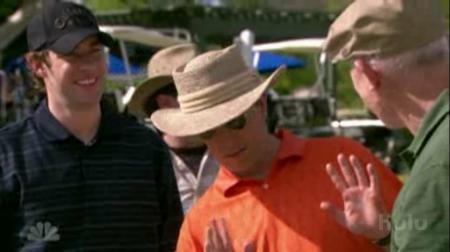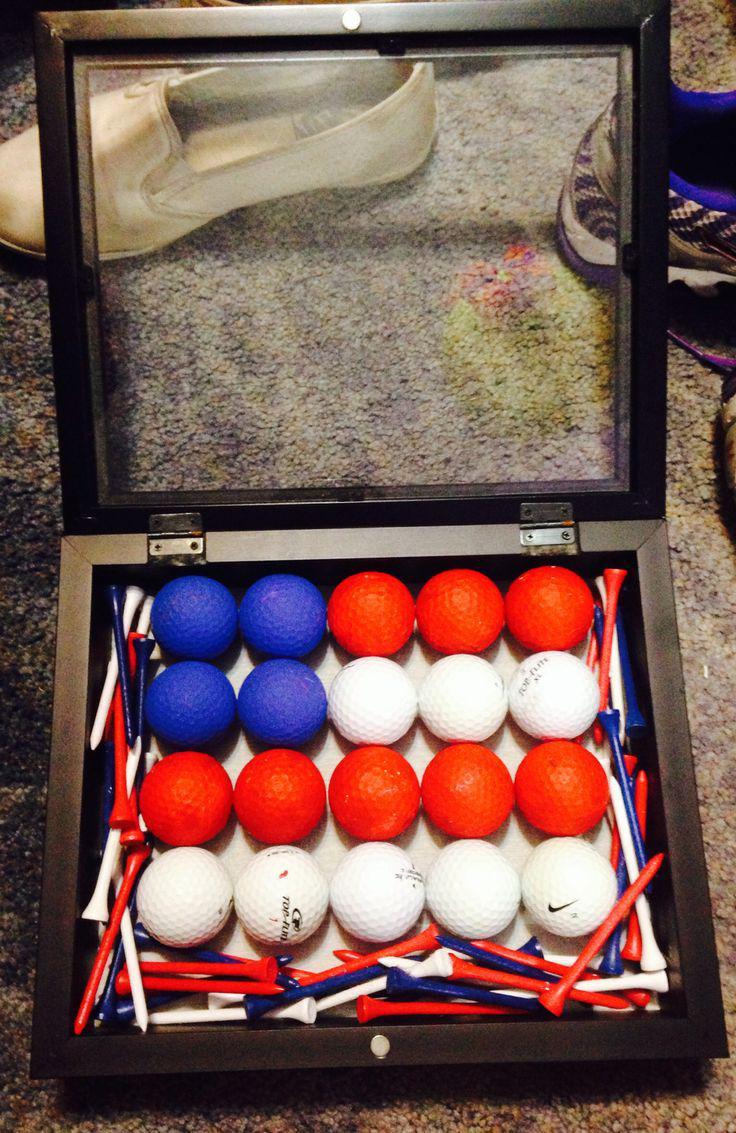The first image is the image on the left, the second image is the image on the right. Considering the images on both sides, is "A person is sitting by golf balls in one of the images." valid? Answer yes or no. No. The first image is the image on the left, the second image is the image on the right. For the images shown, is this caption "There are so many golf balls; much more than twenty." true? Answer yes or no. No. 